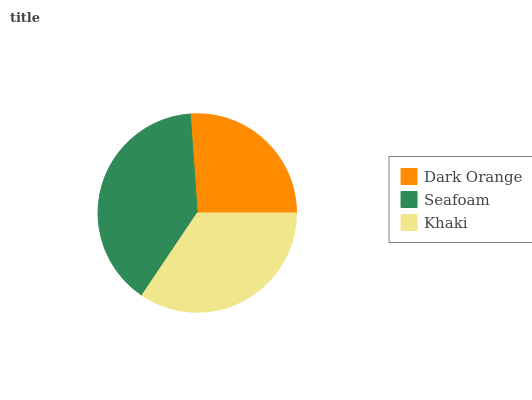Is Dark Orange the minimum?
Answer yes or no. Yes. Is Seafoam the maximum?
Answer yes or no. Yes. Is Khaki the minimum?
Answer yes or no. No. Is Khaki the maximum?
Answer yes or no. No. Is Seafoam greater than Khaki?
Answer yes or no. Yes. Is Khaki less than Seafoam?
Answer yes or no. Yes. Is Khaki greater than Seafoam?
Answer yes or no. No. Is Seafoam less than Khaki?
Answer yes or no. No. Is Khaki the high median?
Answer yes or no. Yes. Is Khaki the low median?
Answer yes or no. Yes. Is Seafoam the high median?
Answer yes or no. No. Is Dark Orange the low median?
Answer yes or no. No. 